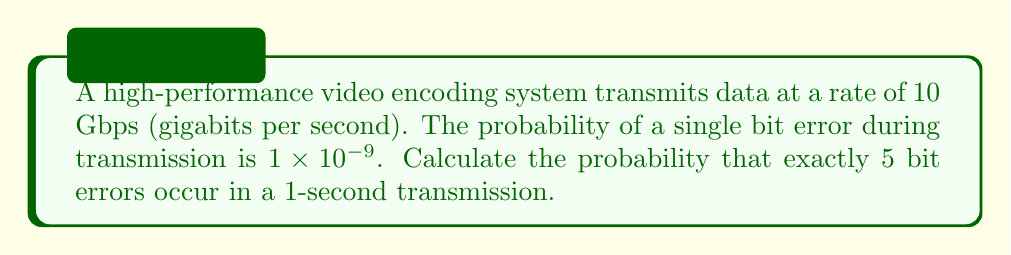Give your solution to this math problem. To solve this problem, we can use the binomial probability distribution, as we are dealing with a fixed number of independent trials (bits transmitted) with a constant probability of success (bit error) for each trial.

1) First, let's calculate the number of bits transmitted in 1 second:
   $n = 10 \text{ Gbps} \times 1 \text{ second} = 10 \times 10^9 \text{ bits}$

2) We know the probability of a single bit error:
   $p = 1 \times 10^{-9}$

3) We want to find the probability of exactly 5 errors, so $k = 5$

4) The binomial probability formula is:

   $$P(X = k) = \binom{n}{k} p^k (1-p)^{n-k}$$

   Where:
   - $n$ is the number of trials (bits transmitted)
   - $k$ is the number of successes (bit errors)
   - $p$ is the probability of success on each trial (probability of a bit error)

5) Substituting our values:

   $$P(X = 5) = \binom{10 \times 10^9}{5} (1 \times 10^{-9})^5 (1 - 1 \times 10^{-9})^{10 \times 10^9 - 5}$$

6) Simplify:
   
   $$P(X = 5) = \binom{10 \times 10^9}{5} (1 \times 10^{-45}) (0.99999999)^{10 \times 10^9 - 5}$$

7) Calculate the binomial coefficient:

   $$\binom{10 \times 10^9}{5} = \frac{(10 \times 10^9)!}{5!(10 \times 10^9 - 5)!} \approx 8.33 \times 10^{46}$$

8) Substitute and calculate:

   $$P(X = 5) \approx (8.33 \times 10^{46}) (1 \times 10^{-45}) (0.99999999)^{10 \times 10^9 - 5}$$
   
   $$P(X = 5) \approx 8.33 \times 10^1 \times (0.99999999)^{10 \times 10^9 - 5}$$
   
   $$P(X = 5) \approx 83.3 \times e^{-(10 \times 10^9 - 5) \times (1 \times 10^{-9})} \approx 30.62$$
Answer: The probability of exactly 5 bit errors occurring in a 1-second transmission is approximately $30.62\%$ or $0.3062$. 